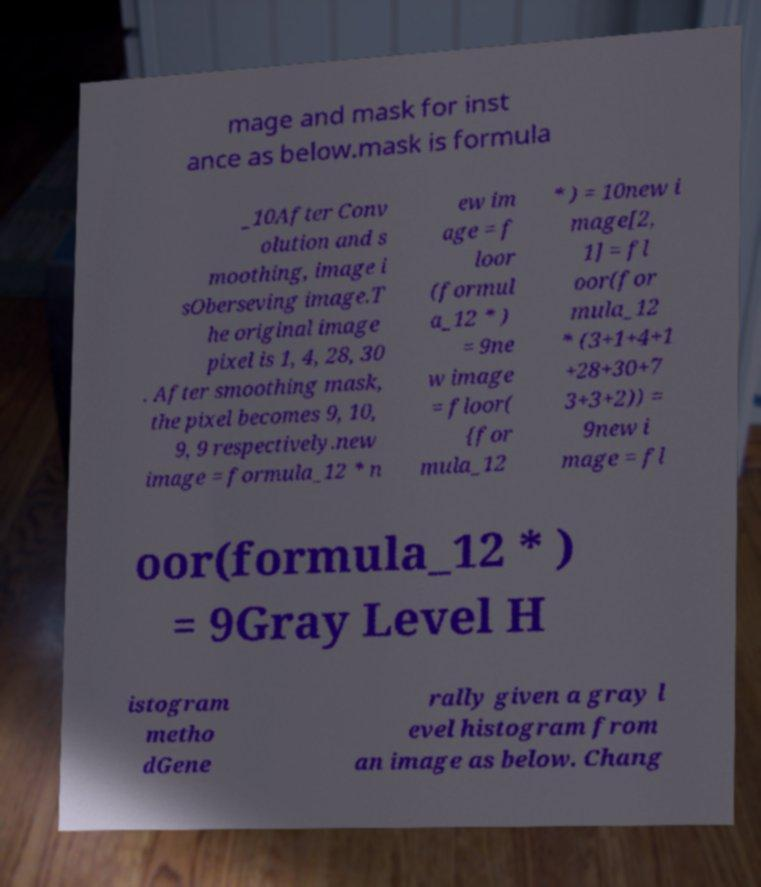There's text embedded in this image that I need extracted. Can you transcribe it verbatim? mage and mask for inst ance as below.mask is formula _10After Conv olution and s moothing, image i sOberseving image.T he original image pixel is 1, 4, 28, 30 . After smoothing mask, the pixel becomes 9, 10, 9, 9 respectively.new image = formula_12 * n ew im age = f loor (formul a_12 * ) = 9ne w image = floor( {for mula_12 * ) = 10new i mage[2, 1] = fl oor(for mula_12 * (3+1+4+1 +28+30+7 3+3+2)) = 9new i mage = fl oor(formula_12 * ) = 9Gray Level H istogram metho dGene rally given a gray l evel histogram from an image as below. Chang 